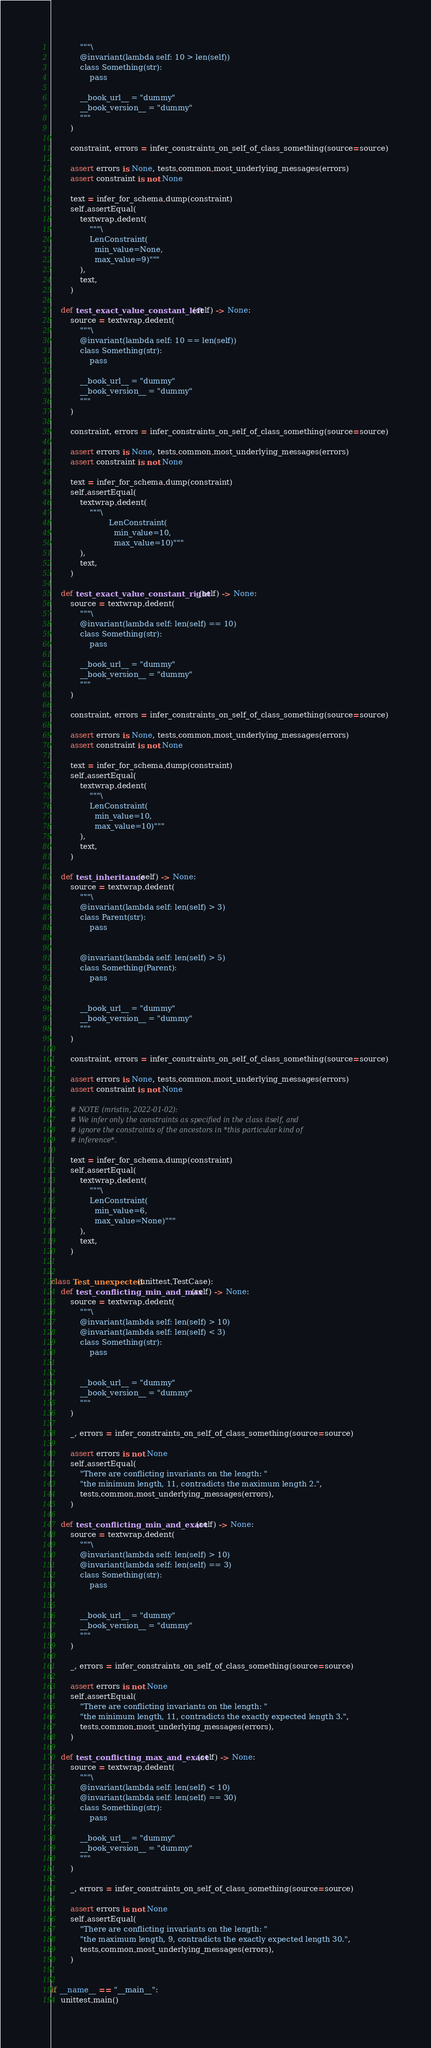<code> <loc_0><loc_0><loc_500><loc_500><_Python_>            """\
            @invariant(lambda self: 10 > len(self))
            class Something(str):
                pass

            __book_url__ = "dummy"
            __book_version__ = "dummy"
            """
        )

        constraint, errors = infer_constraints_on_self_of_class_something(source=source)

        assert errors is None, tests.common.most_underlying_messages(errors)
        assert constraint is not None

        text = infer_for_schema.dump(constraint)
        self.assertEqual(
            textwrap.dedent(
                """\
                LenConstraint(
                  min_value=None,
                  max_value=9)"""
            ),
            text,
        )

    def test_exact_value_constant_left(self) -> None:
        source = textwrap.dedent(
            """\
            @invariant(lambda self: 10 == len(self))
            class Something(str):
                pass

            __book_url__ = "dummy"
            __book_version__ = "dummy"
            """
        )

        constraint, errors = infer_constraints_on_self_of_class_something(source=source)

        assert errors is None, tests.common.most_underlying_messages(errors)
        assert constraint is not None

        text = infer_for_schema.dump(constraint)
        self.assertEqual(
            textwrap.dedent(
                """\
                        LenConstraint(
                          min_value=10,
                          max_value=10)"""
            ),
            text,
        )

    def test_exact_value_constant_right(self) -> None:
        source = textwrap.dedent(
            """\
            @invariant(lambda self: len(self) == 10)
            class Something(str):
                pass

            __book_url__ = "dummy"
            __book_version__ = "dummy"
            """
        )

        constraint, errors = infer_constraints_on_self_of_class_something(source=source)

        assert errors is None, tests.common.most_underlying_messages(errors)
        assert constraint is not None

        text = infer_for_schema.dump(constraint)
        self.assertEqual(
            textwrap.dedent(
                """\
                LenConstraint(
                  min_value=10,
                  max_value=10)"""
            ),
            text,
        )

    def test_inheritance(self) -> None:
        source = textwrap.dedent(
            """\
            @invariant(lambda self: len(self) > 3)
            class Parent(str):
                pass


            @invariant(lambda self: len(self) > 5)
            class Something(Parent):
                pass


            __book_url__ = "dummy"
            __book_version__ = "dummy"
            """
        )

        constraint, errors = infer_constraints_on_self_of_class_something(source=source)

        assert errors is None, tests.common.most_underlying_messages(errors)
        assert constraint is not None

        # NOTE (mristin, 2022-01-02):
        # We infer only the constraints as specified in the class itself, and
        # ignore the constraints of the ancestors in *this particular kind of
        # inference*.

        text = infer_for_schema.dump(constraint)
        self.assertEqual(
            textwrap.dedent(
                """\
                LenConstraint(
                  min_value=6,
                  max_value=None)"""
            ),
            text,
        )


class Test_unexpected(unittest.TestCase):
    def test_conflicting_min_and_max(self) -> None:
        source = textwrap.dedent(
            """\
            @invariant(lambda self: len(self) > 10)
            @invariant(lambda self: len(self) < 3)
            class Something(str):
                pass


            __book_url__ = "dummy"
            __book_version__ = "dummy"
            """
        )

        _, errors = infer_constraints_on_self_of_class_something(source=source)

        assert errors is not None
        self.assertEqual(
            "There are conflicting invariants on the length: "
            "the minimum length, 11, contradicts the maximum length 2.",
            tests.common.most_underlying_messages(errors),
        )

    def test_conflicting_min_and_exact(self) -> None:
        source = textwrap.dedent(
            """\
            @invariant(lambda self: len(self) > 10)
            @invariant(lambda self: len(self) == 3)
            class Something(str):
                pass


            __book_url__ = "dummy"
            __book_version__ = "dummy"
            """
        )

        _, errors = infer_constraints_on_self_of_class_something(source=source)

        assert errors is not None
        self.assertEqual(
            "There are conflicting invariants on the length: "
            "the minimum length, 11, contradicts the exactly expected length 3.",
            tests.common.most_underlying_messages(errors),
        )

    def test_conflicting_max_and_exact(self) -> None:
        source = textwrap.dedent(
            """\
            @invariant(lambda self: len(self) < 10)
            @invariant(lambda self: len(self) == 30)
            class Something(str):
                pass

            __book_url__ = "dummy"
            __book_version__ = "dummy"
            """
        )

        _, errors = infer_constraints_on_self_of_class_something(source=source)

        assert errors is not None
        self.assertEqual(
            "There are conflicting invariants on the length: "
            "the maximum length, 9, contradicts the exactly expected length 30.",
            tests.common.most_underlying_messages(errors),
        )


if __name__ == "__main__":
    unittest.main()
</code> 